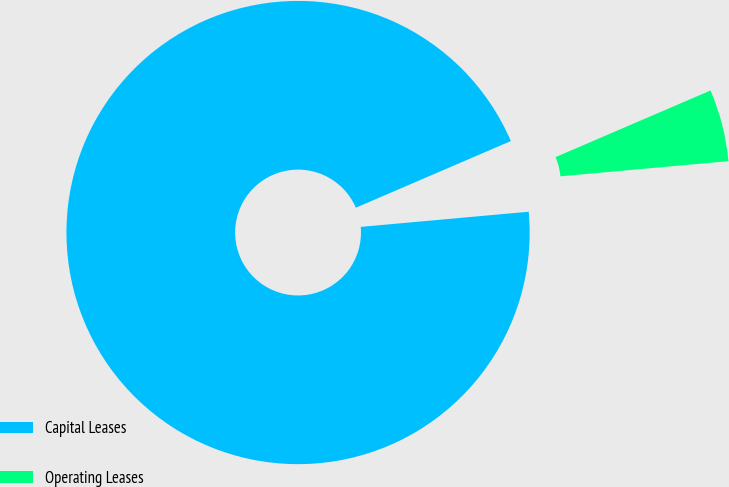Convert chart. <chart><loc_0><loc_0><loc_500><loc_500><pie_chart><fcel>Capital Leases<fcel>Operating Leases<nl><fcel>94.97%<fcel>5.03%<nl></chart> 